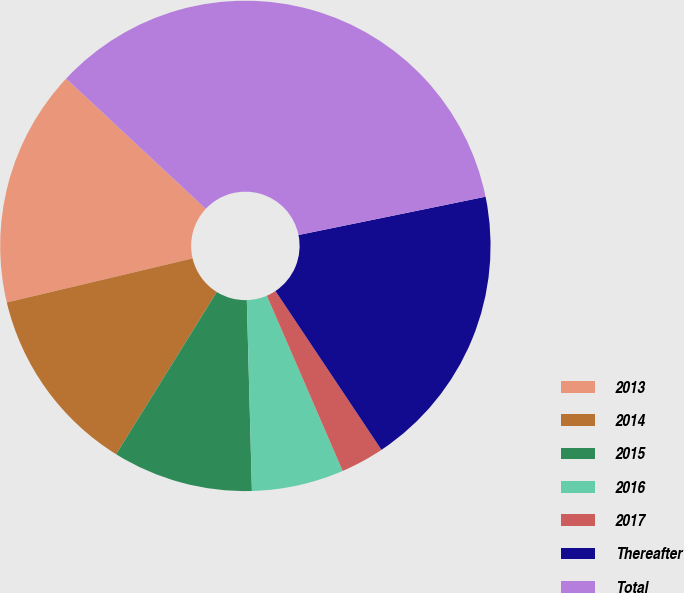<chart> <loc_0><loc_0><loc_500><loc_500><pie_chart><fcel>2013<fcel>2014<fcel>2015<fcel>2016<fcel>2017<fcel>Thereafter<fcel>Total<nl><fcel>15.66%<fcel>12.46%<fcel>9.26%<fcel>6.07%<fcel>2.87%<fcel>18.85%<fcel>34.83%<nl></chart> 